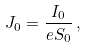Convert formula to latex. <formula><loc_0><loc_0><loc_500><loc_500>J _ { 0 } = \frac { I _ { 0 } } { e S _ { 0 } } \, ,</formula> 